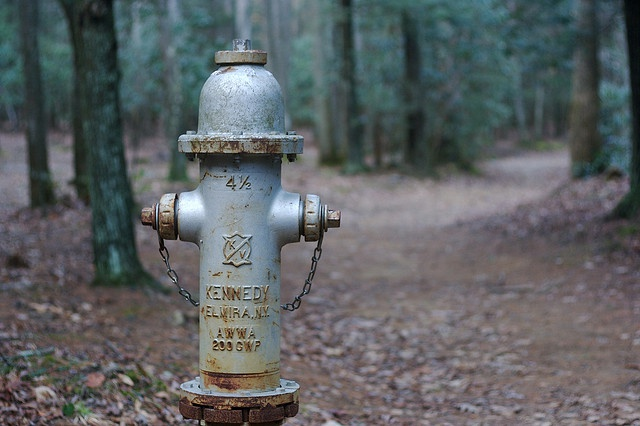Describe the objects in this image and their specific colors. I can see a fire hydrant in blue, darkgray, gray, and black tones in this image. 